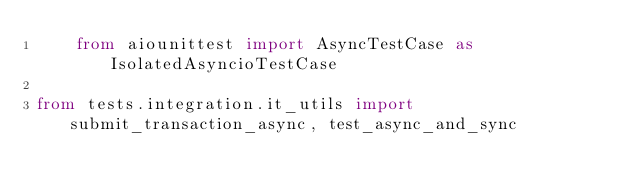Convert code to text. <code><loc_0><loc_0><loc_500><loc_500><_Python_>    from aiounittest import AsyncTestCase as IsolatedAsyncioTestCase

from tests.integration.it_utils import submit_transaction_async, test_async_and_sync</code> 